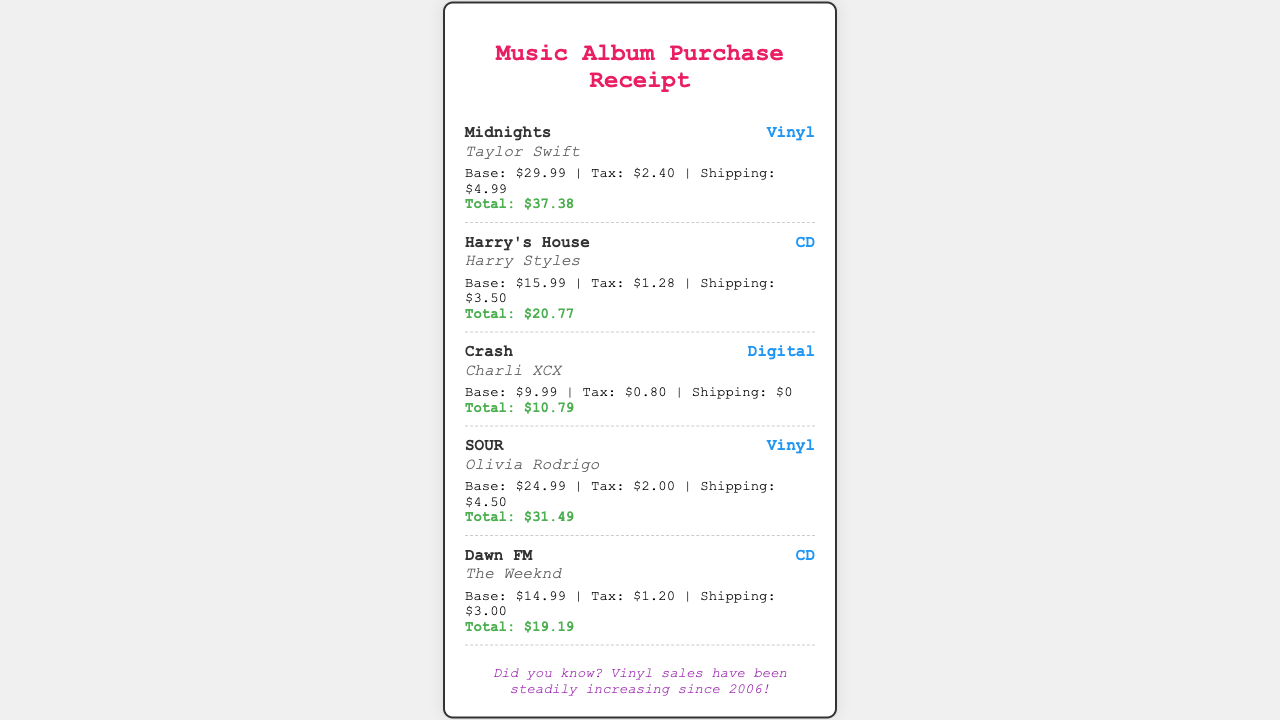What is the title of the album by Taylor Swift? The document lists "Midnights" as the album title associated with Taylor Swift.
Answer: Midnights What format is "Harry's House" available in? The document indicates that "Harry's House" is available in CD format.
Answer: CD What is the total price for "Crash"? The document specifies that the total price for the album "Crash" is $10.79.
Answer: $10.79 Which artist released the album "SOUR"? The document shows that Olivia Rodrigo is the artist for the album "SOUR".
Answer: Olivia Rodrigo What is the shipping cost for "Dawn FM"? According to the document, the shipping cost for "Dawn FM" is $3.00.
Answer: $3.00 What is the base price of the vinyl album? The document includes two vinyl albums, with the lowest base price being $24.99 for "SOUR".
Answer: $24.99 Which album has the highest total price? Based on the document, "Midnights" has the highest total price of $37.38.
Answer: $37.38 How much tax is applied to "Harry's House"? The tax for "Harry's House" is listed as $1.28 in the document.
Answer: $1.28 What does the trivia mention about vinyl sales? The trivia mentions that vinyl sales have been steadily increasing since 2006.
Answer: Increasing since 2006 